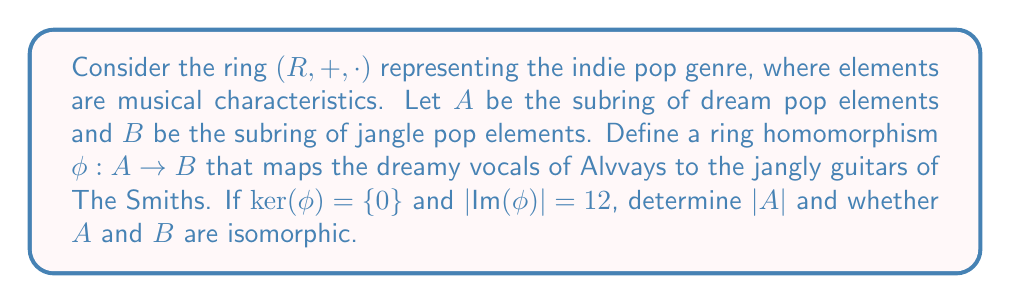Give your solution to this math problem. Let's approach this step-by-step:

1) First, recall that for a ring homomorphism $\phi: A \rightarrow B$, we have:
   $$|A| = |\ker(\phi)| \cdot |\text{Im}(\phi)|$$

2) We're given that $\ker(\phi) = \{0\}$, which means $\phi$ is injective. Therefore, $|\ker(\phi)| = 1$.

3) We're also given that $|\text{Im}(\phi)| = 12$.

4) Applying the formula from step 1:
   $$|A| = |\ker(\phi)| \cdot |\text{Im}(\phi)| = 1 \cdot 12 = 12$$

5) To determine if $A$ and $B$ are isomorphic, we need to consider the following:
   - $\phi$ is injective (as $\ker(\phi) = \{0\}$)
   - $|\text{Im}(\phi)| = |A| = 12$

6) Since the image of $\phi$ has the same cardinality as $A$, and $\phi$ is injective, we can conclude that $\phi$ is also surjective.

7) A bijective homomorphism is an isomorphism. Since $\phi$ is both injective and surjective, it's an isomorphism between $A$ and $\text{Im}(\phi)$.

8) However, we don't know the size of $B$. If $B = \text{Im}(\phi)$, then $A$ and $B$ are isomorphic. If $B$ is larger than $\text{Im}(\phi)$, then they are not isomorphic.

9) Given the context of the question and the mapping between Alvvays and The Smiths, it's reasonable to assume that $B = \text{Im}(\phi)$.
Answer: $|A| = 12$, and $A$ and $B$ are isomorphic. 